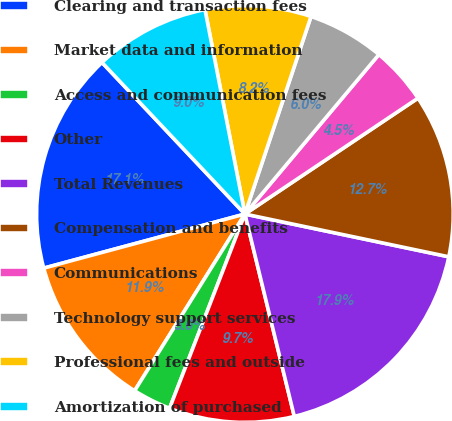<chart> <loc_0><loc_0><loc_500><loc_500><pie_chart><fcel>Clearing and transaction fees<fcel>Market data and information<fcel>Access and communication fees<fcel>Other<fcel>Total Revenues<fcel>Compensation and benefits<fcel>Communications<fcel>Technology support services<fcel>Professional fees and outside<fcel>Amortization of purchased<nl><fcel>17.15%<fcel>11.94%<fcel>2.99%<fcel>9.7%<fcel>17.9%<fcel>12.68%<fcel>4.49%<fcel>5.98%<fcel>8.21%<fcel>8.96%<nl></chart> 